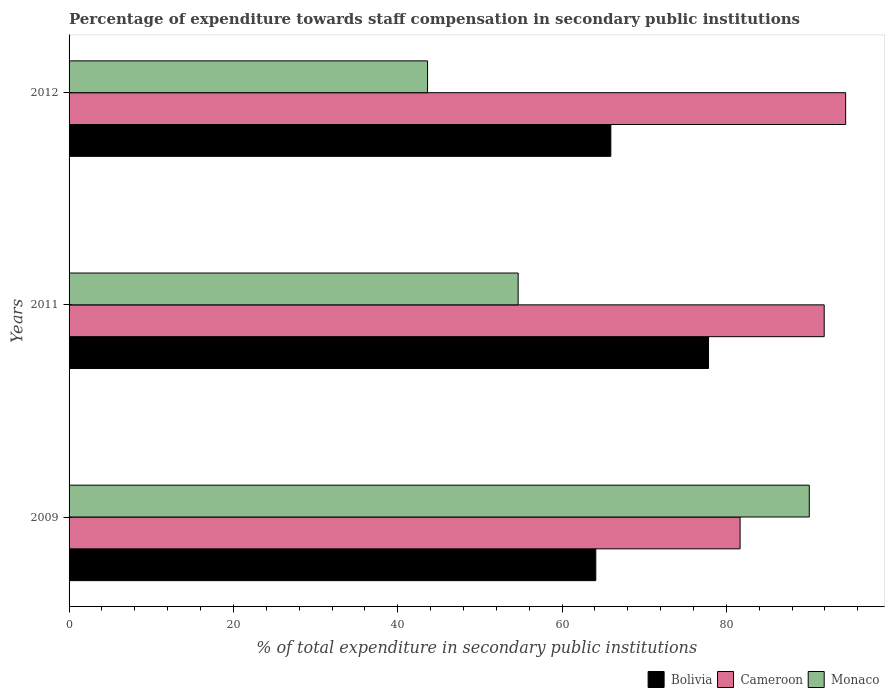How many groups of bars are there?
Make the answer very short. 3. Are the number of bars on each tick of the Y-axis equal?
Your response must be concise. Yes. How many bars are there on the 3rd tick from the top?
Provide a succinct answer. 3. How many bars are there on the 3rd tick from the bottom?
Offer a very short reply. 3. What is the percentage of expenditure towards staff compensation in Monaco in 2009?
Provide a succinct answer. 90.09. Across all years, what is the maximum percentage of expenditure towards staff compensation in Cameroon?
Your response must be concise. 94.52. Across all years, what is the minimum percentage of expenditure towards staff compensation in Bolivia?
Offer a terse response. 64.11. In which year was the percentage of expenditure towards staff compensation in Bolivia maximum?
Offer a very short reply. 2011. What is the total percentage of expenditure towards staff compensation in Bolivia in the graph?
Provide a short and direct response. 207.87. What is the difference between the percentage of expenditure towards staff compensation in Bolivia in 2009 and that in 2012?
Make the answer very short. -1.83. What is the difference between the percentage of expenditure towards staff compensation in Bolivia in 2009 and the percentage of expenditure towards staff compensation in Cameroon in 2011?
Offer a very short reply. -27.8. What is the average percentage of expenditure towards staff compensation in Monaco per year?
Your response must be concise. 62.79. In the year 2009, what is the difference between the percentage of expenditure towards staff compensation in Cameroon and percentage of expenditure towards staff compensation in Bolivia?
Provide a short and direct response. 17.56. What is the ratio of the percentage of expenditure towards staff compensation in Monaco in 2011 to that in 2012?
Your answer should be compact. 1.25. Is the percentage of expenditure towards staff compensation in Cameroon in 2011 less than that in 2012?
Your response must be concise. Yes. What is the difference between the highest and the second highest percentage of expenditure towards staff compensation in Cameroon?
Make the answer very short. 2.61. What is the difference between the highest and the lowest percentage of expenditure towards staff compensation in Cameroon?
Your answer should be very brief. 12.85. What does the 1st bar from the top in 2009 represents?
Ensure brevity in your answer.  Monaco. What is the title of the graph?
Your answer should be compact. Percentage of expenditure towards staff compensation in secondary public institutions. Does "Latin America(developing only)" appear as one of the legend labels in the graph?
Give a very brief answer. No. What is the label or title of the X-axis?
Offer a very short reply. % of total expenditure in secondary public institutions. What is the label or title of the Y-axis?
Provide a short and direct response. Years. What is the % of total expenditure in secondary public institutions of Bolivia in 2009?
Keep it short and to the point. 64.11. What is the % of total expenditure in secondary public institutions of Cameroon in 2009?
Offer a very short reply. 81.67. What is the % of total expenditure in secondary public institutions in Monaco in 2009?
Give a very brief answer. 90.09. What is the % of total expenditure in secondary public institutions in Bolivia in 2011?
Your answer should be very brief. 77.83. What is the % of total expenditure in secondary public institutions of Cameroon in 2011?
Offer a terse response. 91.9. What is the % of total expenditure in secondary public institutions of Monaco in 2011?
Provide a short and direct response. 54.66. What is the % of total expenditure in secondary public institutions of Bolivia in 2012?
Your answer should be very brief. 65.94. What is the % of total expenditure in secondary public institutions in Cameroon in 2012?
Ensure brevity in your answer.  94.52. What is the % of total expenditure in secondary public institutions of Monaco in 2012?
Offer a terse response. 43.63. Across all years, what is the maximum % of total expenditure in secondary public institutions of Bolivia?
Keep it short and to the point. 77.83. Across all years, what is the maximum % of total expenditure in secondary public institutions of Cameroon?
Your answer should be compact. 94.52. Across all years, what is the maximum % of total expenditure in secondary public institutions of Monaco?
Your answer should be compact. 90.09. Across all years, what is the minimum % of total expenditure in secondary public institutions in Bolivia?
Make the answer very short. 64.11. Across all years, what is the minimum % of total expenditure in secondary public institutions of Cameroon?
Provide a short and direct response. 81.67. Across all years, what is the minimum % of total expenditure in secondary public institutions in Monaco?
Offer a very short reply. 43.63. What is the total % of total expenditure in secondary public institutions of Bolivia in the graph?
Give a very brief answer. 207.87. What is the total % of total expenditure in secondary public institutions of Cameroon in the graph?
Your answer should be very brief. 268.09. What is the total % of total expenditure in secondary public institutions in Monaco in the graph?
Make the answer very short. 188.37. What is the difference between the % of total expenditure in secondary public institutions of Bolivia in 2009 and that in 2011?
Make the answer very short. -13.72. What is the difference between the % of total expenditure in secondary public institutions of Cameroon in 2009 and that in 2011?
Your answer should be very brief. -10.24. What is the difference between the % of total expenditure in secondary public institutions in Monaco in 2009 and that in 2011?
Offer a terse response. 35.43. What is the difference between the % of total expenditure in secondary public institutions of Bolivia in 2009 and that in 2012?
Your answer should be very brief. -1.83. What is the difference between the % of total expenditure in secondary public institutions of Cameroon in 2009 and that in 2012?
Provide a succinct answer. -12.85. What is the difference between the % of total expenditure in secondary public institutions of Monaco in 2009 and that in 2012?
Offer a terse response. 46.46. What is the difference between the % of total expenditure in secondary public institutions in Bolivia in 2011 and that in 2012?
Keep it short and to the point. 11.89. What is the difference between the % of total expenditure in secondary public institutions of Cameroon in 2011 and that in 2012?
Give a very brief answer. -2.61. What is the difference between the % of total expenditure in secondary public institutions of Monaco in 2011 and that in 2012?
Ensure brevity in your answer.  11.03. What is the difference between the % of total expenditure in secondary public institutions of Bolivia in 2009 and the % of total expenditure in secondary public institutions of Cameroon in 2011?
Make the answer very short. -27.8. What is the difference between the % of total expenditure in secondary public institutions in Bolivia in 2009 and the % of total expenditure in secondary public institutions in Monaco in 2011?
Give a very brief answer. 9.45. What is the difference between the % of total expenditure in secondary public institutions of Cameroon in 2009 and the % of total expenditure in secondary public institutions of Monaco in 2011?
Offer a terse response. 27.01. What is the difference between the % of total expenditure in secondary public institutions in Bolivia in 2009 and the % of total expenditure in secondary public institutions in Cameroon in 2012?
Your response must be concise. -30.41. What is the difference between the % of total expenditure in secondary public institutions in Bolivia in 2009 and the % of total expenditure in secondary public institutions in Monaco in 2012?
Ensure brevity in your answer.  20.48. What is the difference between the % of total expenditure in secondary public institutions in Cameroon in 2009 and the % of total expenditure in secondary public institutions in Monaco in 2012?
Your answer should be compact. 38.04. What is the difference between the % of total expenditure in secondary public institutions in Bolivia in 2011 and the % of total expenditure in secondary public institutions in Cameroon in 2012?
Provide a succinct answer. -16.69. What is the difference between the % of total expenditure in secondary public institutions of Bolivia in 2011 and the % of total expenditure in secondary public institutions of Monaco in 2012?
Your answer should be compact. 34.2. What is the difference between the % of total expenditure in secondary public institutions of Cameroon in 2011 and the % of total expenditure in secondary public institutions of Monaco in 2012?
Keep it short and to the point. 48.28. What is the average % of total expenditure in secondary public institutions in Bolivia per year?
Ensure brevity in your answer.  69.29. What is the average % of total expenditure in secondary public institutions of Cameroon per year?
Provide a succinct answer. 89.36. What is the average % of total expenditure in secondary public institutions in Monaco per year?
Your response must be concise. 62.79. In the year 2009, what is the difference between the % of total expenditure in secondary public institutions in Bolivia and % of total expenditure in secondary public institutions in Cameroon?
Your response must be concise. -17.56. In the year 2009, what is the difference between the % of total expenditure in secondary public institutions in Bolivia and % of total expenditure in secondary public institutions in Monaco?
Give a very brief answer. -25.98. In the year 2009, what is the difference between the % of total expenditure in secondary public institutions of Cameroon and % of total expenditure in secondary public institutions of Monaco?
Offer a terse response. -8.42. In the year 2011, what is the difference between the % of total expenditure in secondary public institutions of Bolivia and % of total expenditure in secondary public institutions of Cameroon?
Ensure brevity in your answer.  -14.08. In the year 2011, what is the difference between the % of total expenditure in secondary public institutions of Bolivia and % of total expenditure in secondary public institutions of Monaco?
Give a very brief answer. 23.17. In the year 2011, what is the difference between the % of total expenditure in secondary public institutions of Cameroon and % of total expenditure in secondary public institutions of Monaco?
Ensure brevity in your answer.  37.25. In the year 2012, what is the difference between the % of total expenditure in secondary public institutions of Bolivia and % of total expenditure in secondary public institutions of Cameroon?
Keep it short and to the point. -28.58. In the year 2012, what is the difference between the % of total expenditure in secondary public institutions of Bolivia and % of total expenditure in secondary public institutions of Monaco?
Provide a short and direct response. 22.31. In the year 2012, what is the difference between the % of total expenditure in secondary public institutions in Cameroon and % of total expenditure in secondary public institutions in Monaco?
Your answer should be very brief. 50.89. What is the ratio of the % of total expenditure in secondary public institutions in Bolivia in 2009 to that in 2011?
Give a very brief answer. 0.82. What is the ratio of the % of total expenditure in secondary public institutions of Cameroon in 2009 to that in 2011?
Ensure brevity in your answer.  0.89. What is the ratio of the % of total expenditure in secondary public institutions in Monaco in 2009 to that in 2011?
Make the answer very short. 1.65. What is the ratio of the % of total expenditure in secondary public institutions of Bolivia in 2009 to that in 2012?
Your response must be concise. 0.97. What is the ratio of the % of total expenditure in secondary public institutions of Cameroon in 2009 to that in 2012?
Ensure brevity in your answer.  0.86. What is the ratio of the % of total expenditure in secondary public institutions in Monaco in 2009 to that in 2012?
Give a very brief answer. 2.06. What is the ratio of the % of total expenditure in secondary public institutions in Bolivia in 2011 to that in 2012?
Provide a short and direct response. 1.18. What is the ratio of the % of total expenditure in secondary public institutions of Cameroon in 2011 to that in 2012?
Provide a succinct answer. 0.97. What is the ratio of the % of total expenditure in secondary public institutions in Monaco in 2011 to that in 2012?
Ensure brevity in your answer.  1.25. What is the difference between the highest and the second highest % of total expenditure in secondary public institutions in Bolivia?
Ensure brevity in your answer.  11.89. What is the difference between the highest and the second highest % of total expenditure in secondary public institutions of Cameroon?
Ensure brevity in your answer.  2.61. What is the difference between the highest and the second highest % of total expenditure in secondary public institutions in Monaco?
Offer a very short reply. 35.43. What is the difference between the highest and the lowest % of total expenditure in secondary public institutions of Bolivia?
Your answer should be very brief. 13.72. What is the difference between the highest and the lowest % of total expenditure in secondary public institutions in Cameroon?
Your answer should be compact. 12.85. What is the difference between the highest and the lowest % of total expenditure in secondary public institutions of Monaco?
Make the answer very short. 46.46. 